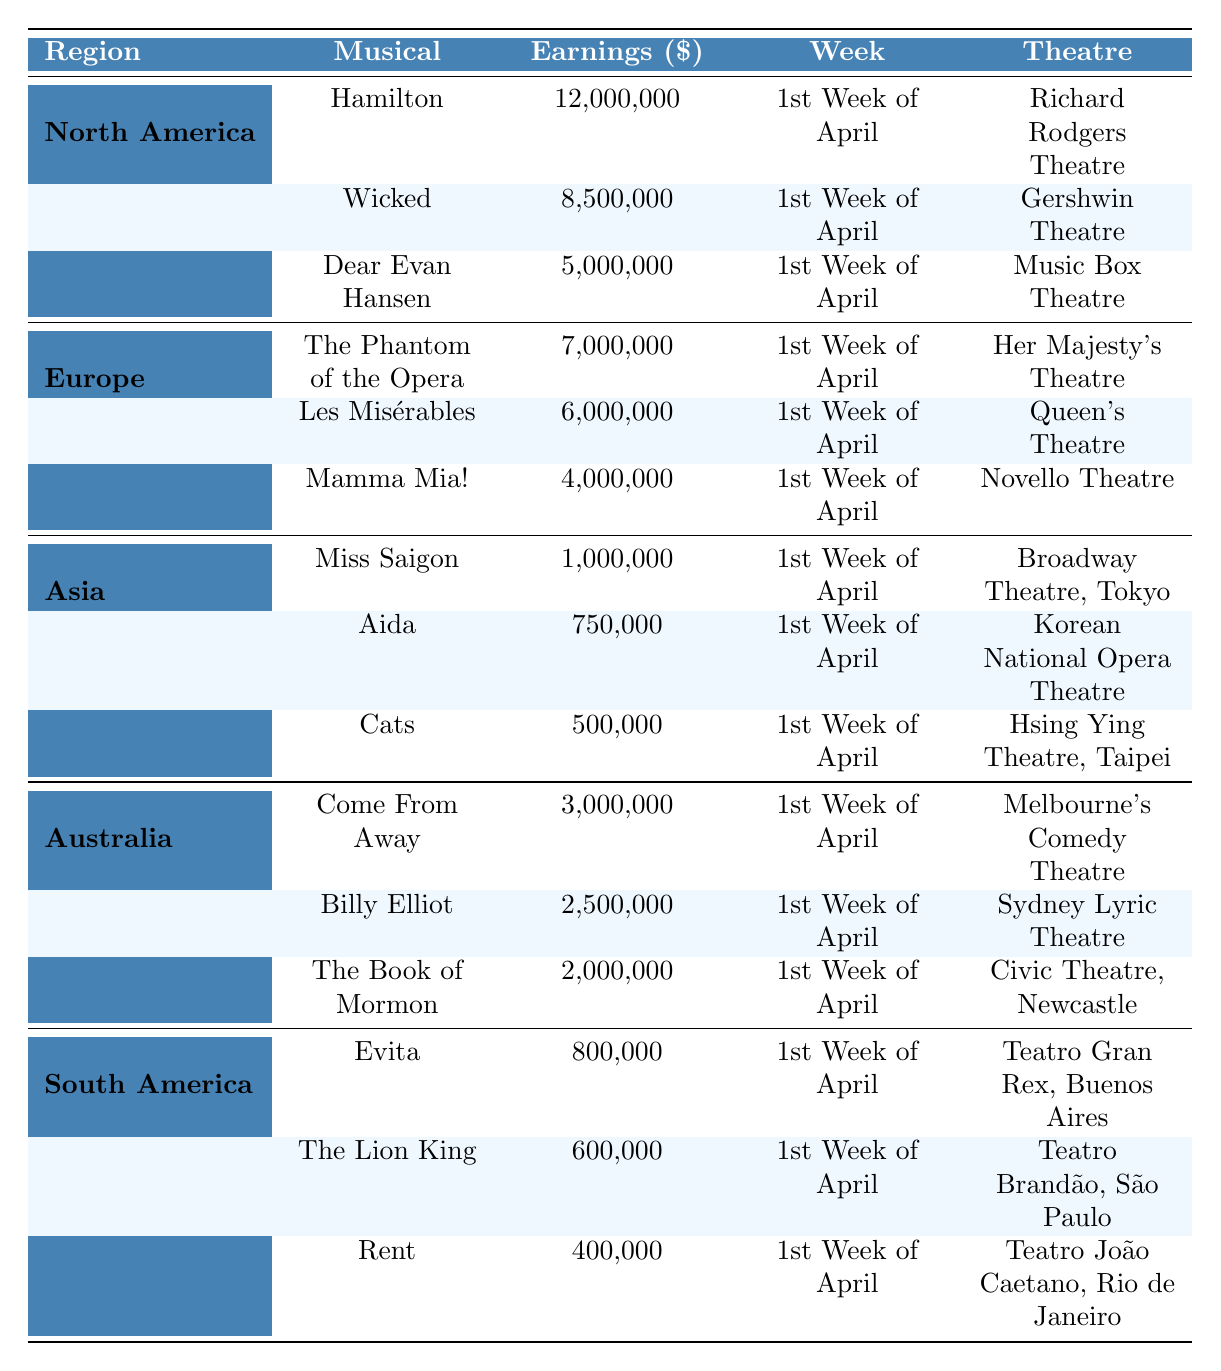What is the total box office earning for musicals in North America? The total earnings from North America can be calculated by summing the earnings of all musicals listed under that region: 12,000,000 (Hamilton) + 8,500,000 (Wicked) + 5,000,000 (Dear Evan Hansen) = 25,500,000.
Answer: 25,500,000 Which musical had the highest earnings in Asia? Comparing the earnings of the musicals in Asia, Miss Saigon earned 1,000,000, Aida earned 750,000, and Cats earned 500,000. Therefore, Miss Saigon has the highest earnings.
Answer: Miss Saigon Is there a musical in Europe that earned more than 5 million dollars? The musicals listed in Europe include The Phantom of the Opera (7,000,000), Les Misérables (6,000,000), and Mamma Mia! (4,000,000). Both The Phantom of the Opera and Les Misérables earned more than 5 million dollars, confirming the fact.
Answer: Yes What is the total earnings of all musicals in Australia? To find the total earnings in Australia, sum the earnings of Come From Away (3,000,000), Billy Elliot (2,500,000), and The Book of Mormon (2,000,000): 3,000,000 + 2,500,000 + 2,000,000 = 7,500,000.
Answer: 7,500,000 Which region had the musical with the lowest earnings? The lowest earnings of all listed musicals are from Cats in Asia, with earnings of 500,000. Therefore, Asia had the musical with the lowest earnings.
Answer: Asia How much more did Hamilton earn compared to Evita? Hamilton's earnings are 12,000,000 and Evita’s earnings are 800,000. The difference in earnings is 12,000,000 - 800,000 = 11,200,000.
Answer: 11,200,000 Which theatre hosted the most successful musical in North America? The most successful musical in North America is Hamilton at the Richard Rodgers Theatre, with earnings of 12,000,000, which is higher than those of other musicals listed in the region.
Answer: Richard Rodgers Theatre What is the average earnings of musicals in Europe? The earnings for musicals in Europe are: The Phantom of the Opera (7,000,000), Les Misérables (6,000,000), and Mamma Mia! (4,000,000). Summing these gives 17,000,000 and dividing by the number of musicals (3) gives an average of 17,000,000 / 3 = 5,666,666.67.
Answer: 5,666,666.67 Which musical earned the least in South America? The earnings in South America are: Evita (800,000), The Lion King (600,000), and Rent (400,000). The least earning musical is Rent with 400,000.
Answer: Rent Did any musical in Australia earn less than 2 million dollars? The musicals in Australia include Come From Away (3,000,000), Billy Elliot (2,500,000), and The Book of Mormon (2,000,000). All these earnings are equal to or greater than 2 million dollars, so there are none that earned less.
Answer: No 